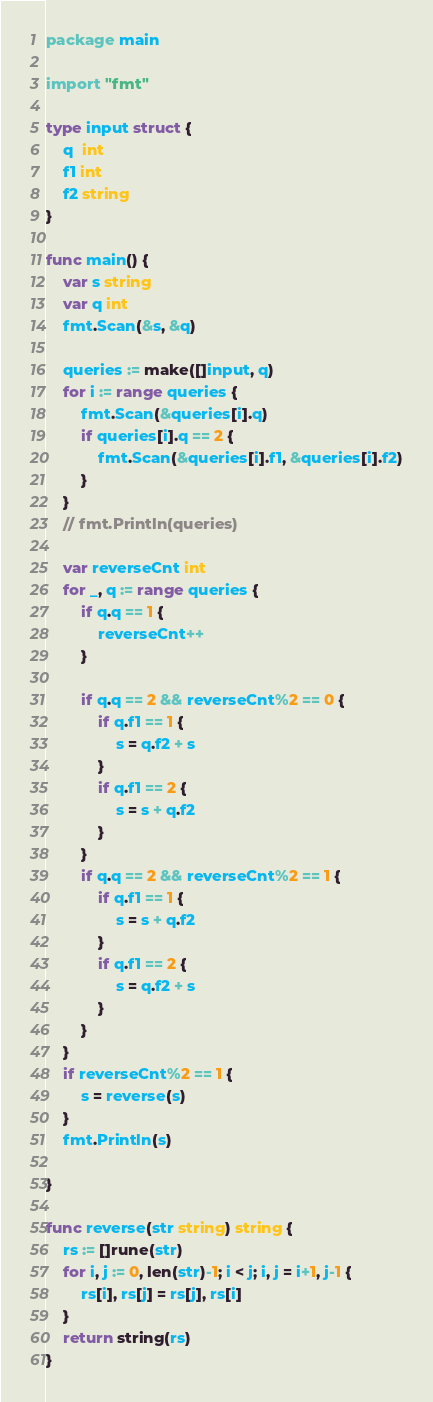Convert code to text. <code><loc_0><loc_0><loc_500><loc_500><_Go_>package main

import "fmt"

type input struct {
	q  int
	f1 int
	f2 string
}

func main() {
	var s string
	var q int
	fmt.Scan(&s, &q)

	queries := make([]input, q)
	for i := range queries {
		fmt.Scan(&queries[i].q)
		if queries[i].q == 2 {
			fmt.Scan(&queries[i].f1, &queries[i].f2)
		}
	}
	// fmt.Println(queries)

	var reverseCnt int
	for _, q := range queries {
		if q.q == 1 {
			reverseCnt++
		}

		if q.q == 2 && reverseCnt%2 == 0 {
			if q.f1 == 1 {
				s = q.f2 + s
			}
			if q.f1 == 2 {
				s = s + q.f2
			}
		}
		if q.q == 2 && reverseCnt%2 == 1 {
			if q.f1 == 1 {
				s = s + q.f2
			}
			if q.f1 == 2 {
				s = q.f2 + s
			}
		}
	}
	if reverseCnt%2 == 1 {
		s = reverse(s)
	}
	fmt.Println(s)

}

func reverse(str string) string {
	rs := []rune(str)
	for i, j := 0, len(str)-1; i < j; i, j = i+1, j-1 {
		rs[i], rs[j] = rs[j], rs[i]
	}
	return string(rs)
}
</code> 